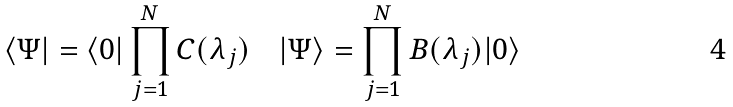Convert formula to latex. <formula><loc_0><loc_0><loc_500><loc_500>\langle \Psi | = \langle 0 | \prod _ { j = 1 } ^ { N } C ( \lambda _ { j } ) \quad | \Psi \rangle = \prod _ { j = 1 } ^ { N } B ( \lambda _ { j } ) | 0 \rangle</formula> 